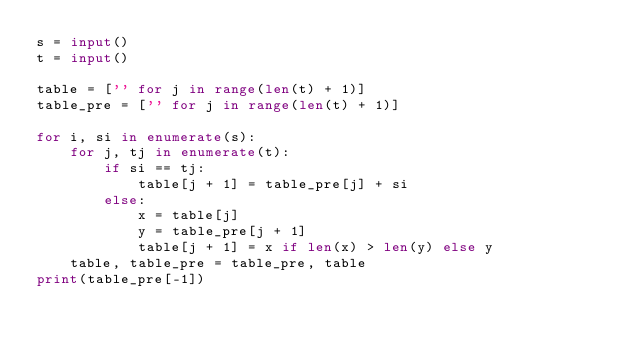<code> <loc_0><loc_0><loc_500><loc_500><_Python_>s = input()
t = input()

table = ['' for j in range(len(t) + 1)]
table_pre = ['' for j in range(len(t) + 1)]

for i, si in enumerate(s):
    for j, tj in enumerate(t):
        if si == tj:
            table[j + 1] = table_pre[j] + si
        else:
            x = table[j]
            y = table_pre[j + 1]
            table[j + 1] = x if len(x) > len(y) else y
    table, table_pre = table_pre, table
print(table_pre[-1])
</code> 